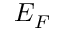Convert formula to latex. <formula><loc_0><loc_0><loc_500><loc_500>E _ { F }</formula> 